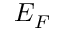Convert formula to latex. <formula><loc_0><loc_0><loc_500><loc_500>E _ { F }</formula> 